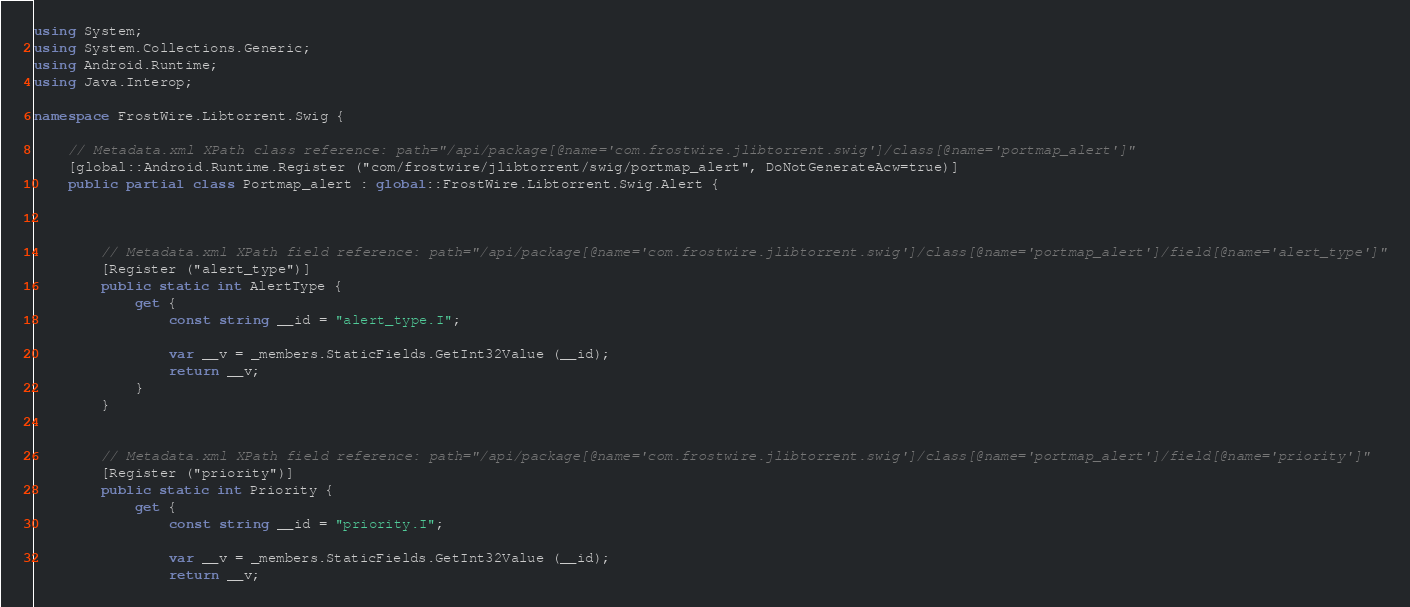Convert code to text. <code><loc_0><loc_0><loc_500><loc_500><_C#_>using System;
using System.Collections.Generic;
using Android.Runtime;
using Java.Interop;

namespace FrostWire.Libtorrent.Swig {

	// Metadata.xml XPath class reference: path="/api/package[@name='com.frostwire.jlibtorrent.swig']/class[@name='portmap_alert']"
	[global::Android.Runtime.Register ("com/frostwire/jlibtorrent/swig/portmap_alert", DoNotGenerateAcw=true)]
	public partial class Portmap_alert : global::FrostWire.Libtorrent.Swig.Alert {



		// Metadata.xml XPath field reference: path="/api/package[@name='com.frostwire.jlibtorrent.swig']/class[@name='portmap_alert']/field[@name='alert_type']"
		[Register ("alert_type")]
		public static int AlertType {
			get {
				const string __id = "alert_type.I";

				var __v = _members.StaticFields.GetInt32Value (__id);
				return __v;
			}
		}


		// Metadata.xml XPath field reference: path="/api/package[@name='com.frostwire.jlibtorrent.swig']/class[@name='portmap_alert']/field[@name='priority']"
		[Register ("priority")]
		public static int Priority {
			get {
				const string __id = "priority.I";

				var __v = _members.StaticFields.GetInt32Value (__id);
				return __v;</code> 